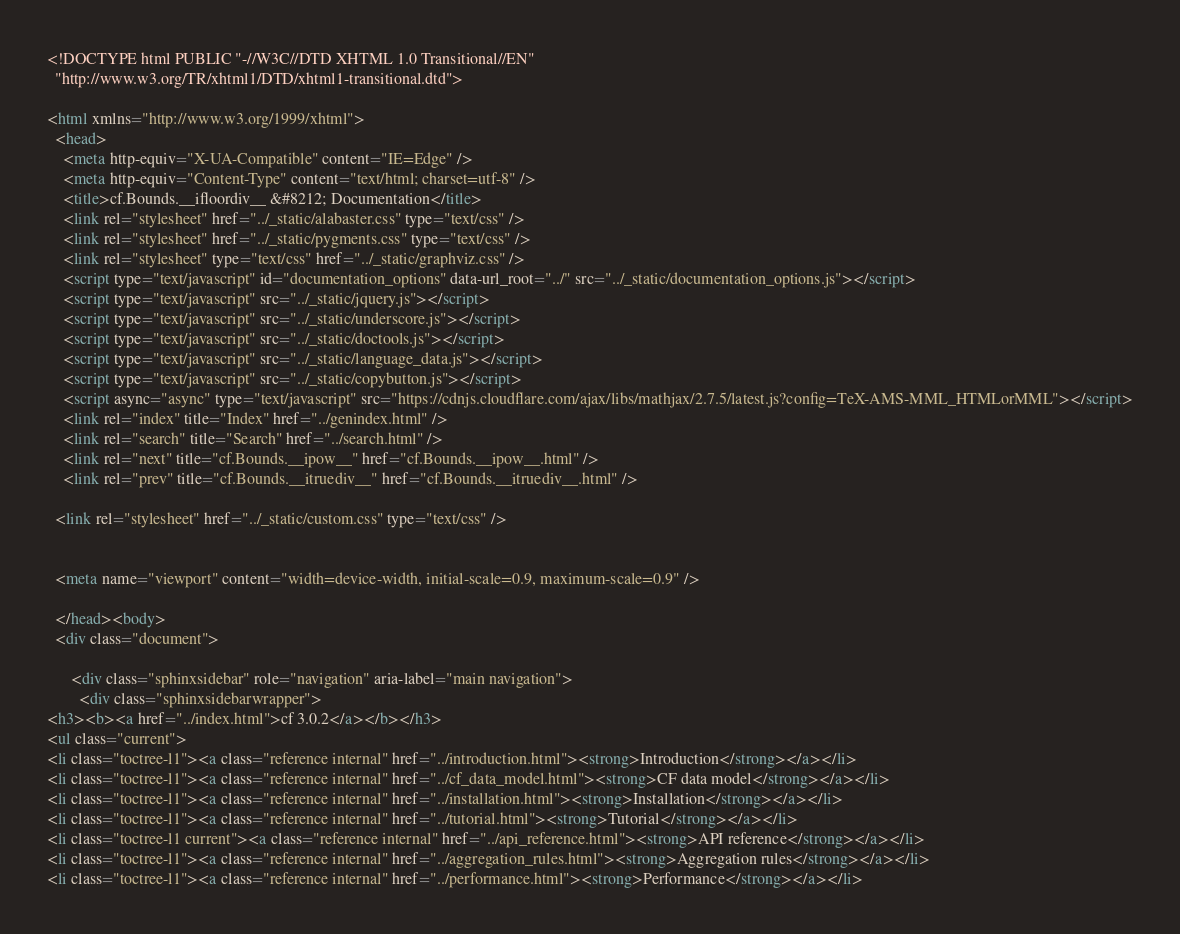Convert code to text. <code><loc_0><loc_0><loc_500><loc_500><_HTML_>
<!DOCTYPE html PUBLIC "-//W3C//DTD XHTML 1.0 Transitional//EN"
  "http://www.w3.org/TR/xhtml1/DTD/xhtml1-transitional.dtd">

<html xmlns="http://www.w3.org/1999/xhtml">
  <head>
    <meta http-equiv="X-UA-Compatible" content="IE=Edge" />
    <meta http-equiv="Content-Type" content="text/html; charset=utf-8" />
    <title>cf.Bounds.__ifloordiv__ &#8212; Documentation</title>
    <link rel="stylesheet" href="../_static/alabaster.css" type="text/css" />
    <link rel="stylesheet" href="../_static/pygments.css" type="text/css" />
    <link rel="stylesheet" type="text/css" href="../_static/graphviz.css" />
    <script type="text/javascript" id="documentation_options" data-url_root="../" src="../_static/documentation_options.js"></script>
    <script type="text/javascript" src="../_static/jquery.js"></script>
    <script type="text/javascript" src="../_static/underscore.js"></script>
    <script type="text/javascript" src="../_static/doctools.js"></script>
    <script type="text/javascript" src="../_static/language_data.js"></script>
    <script type="text/javascript" src="../_static/copybutton.js"></script>
    <script async="async" type="text/javascript" src="https://cdnjs.cloudflare.com/ajax/libs/mathjax/2.7.5/latest.js?config=TeX-AMS-MML_HTMLorMML"></script>
    <link rel="index" title="Index" href="../genindex.html" />
    <link rel="search" title="Search" href="../search.html" />
    <link rel="next" title="cf.Bounds.__ipow__" href="cf.Bounds.__ipow__.html" />
    <link rel="prev" title="cf.Bounds.__itruediv__" href="cf.Bounds.__itruediv__.html" />
   
  <link rel="stylesheet" href="../_static/custom.css" type="text/css" />
  
  
  <meta name="viewport" content="width=device-width, initial-scale=0.9, maximum-scale=0.9" />

  </head><body>
  <div class="document">
    
      <div class="sphinxsidebar" role="navigation" aria-label="main navigation">
        <div class="sphinxsidebarwrapper">
<h3><b><a href="../index.html">cf 3.0.2</a></b></h3>
<ul class="current">
<li class="toctree-l1"><a class="reference internal" href="../introduction.html"><strong>Introduction</strong></a></li>
<li class="toctree-l1"><a class="reference internal" href="../cf_data_model.html"><strong>CF data model</strong></a></li>
<li class="toctree-l1"><a class="reference internal" href="../installation.html"><strong>Installation</strong></a></li>
<li class="toctree-l1"><a class="reference internal" href="../tutorial.html"><strong>Tutorial</strong></a></li>
<li class="toctree-l1 current"><a class="reference internal" href="../api_reference.html"><strong>API reference</strong></a></li>
<li class="toctree-l1"><a class="reference internal" href="../aggregation_rules.html"><strong>Aggregation rules</strong></a></li>
<li class="toctree-l1"><a class="reference internal" href="../performance.html"><strong>Performance</strong></a></li></code> 